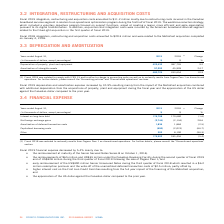According to Cogeco's financial document, What was the increase in the depreciation and amortization expense in 2019? According to the financial document, 10.9%. The relevant text states: "depreciation and amortization expense increased by 10.9% resulting mainly from the impact of the MetroCast acquisition combined with additional depreciation..." Also, Fiscal 2018 was reinstated to which accounting standard? According to the financial document, IFRS 15. The relevant text states: "(1) Fiscal 2018 was restated to comply with IFRS 15 and to reflect a change in accounting policy as well as to reclassify results from Cogeco Peer 1 as..." Also, What was the Depreciation of property, plant and equipment in 2019? According to the financial document, 423,432 (in thousands). The relevant text states: "Depreciation of property, plant and equipment 423,432 387,726 9.2..." Also, can you calculate: What was the increase / (decrease) in the Depreciation of property, plant and equipment from 2018 to 2019? Based on the calculation: 423,432 - 387,726, the result is 35706 (in thousands). This is based on the information: "eciation of property, plant and equipment 423,432 387,726 9.2 Depreciation of property, plant and equipment 423,432 387,726 9.2..." The key data points involved are: 387,726, 423,432. Also, can you calculate: What was the average Amortization of intangible assets between 2018 and 2019? To answer this question, I need to perform calculations using the financial data. The calculation is: (57,293 + 45,928) / 2, which equals 51610.5 (in thousands). This is based on the information: "Amortization of intangible assets 57,293 45,928 24.7 Amortization of intangible assets 57,293 45,928 24.7..." The key data points involved are: 45,928, 57,293. Also, can you calculate: What was the increase / (decrease) in Amortization of intangible assets from 2018 to 2019? Based on the calculation: 57,293 - 45,928, the result is 11365 (in thousands). This is based on the information: "Amortization of intangible assets 57,293 45,928 24.7 Amortization of intangible assets 57,293 45,928 24.7..." The key data points involved are: 45,928, 57,293. 